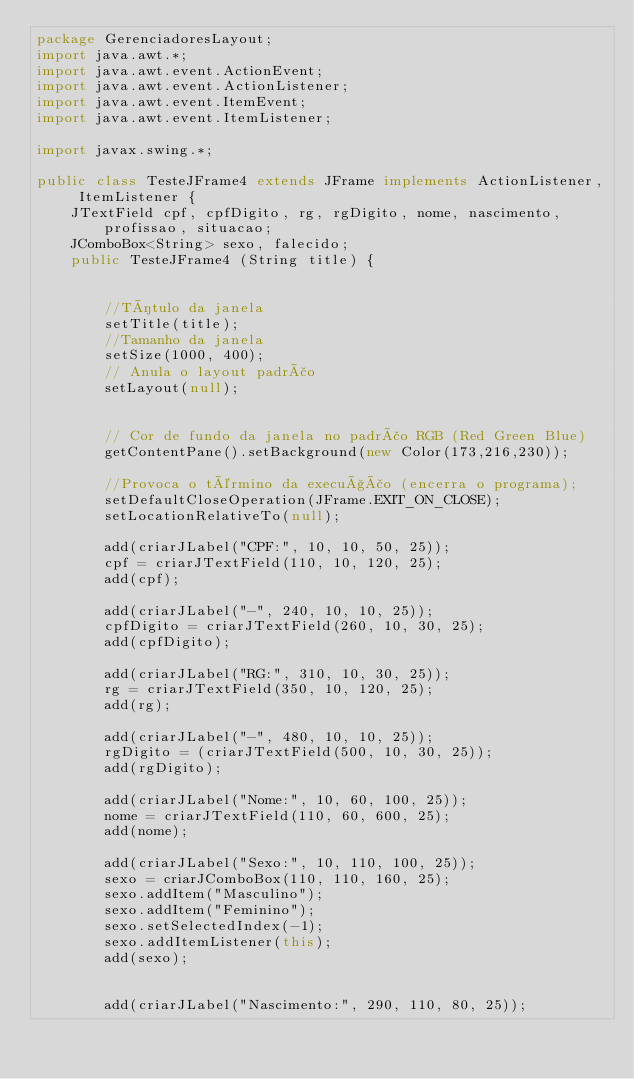Convert code to text. <code><loc_0><loc_0><loc_500><loc_500><_Java_>package GerenciadoresLayout;
import java.awt.*;
import java.awt.event.ActionEvent;
import java.awt.event.ActionListener;
import java.awt.event.ItemEvent;
import java.awt.event.ItemListener;

import javax.swing.*;

public class TesteJFrame4 extends JFrame implements ActionListener, ItemListener {
    JTextField cpf, cpfDigito, rg, rgDigito, nome, nascimento, profissao, situacao;
    JComboBox<String> sexo, falecido;
    public TesteJFrame4 (String title) {


        //Título da janela
        setTitle(title);
        //Tamanho da janela
        setSize(1000, 400);
        // Anula o layout padrão
        setLayout(null);


        // Cor de fundo da janela no padrão RGB (Red Green Blue)
        getContentPane().setBackground(new Color(173,216,230));

        //Provoca o término da execução (encerra o programa);
        setDefaultCloseOperation(JFrame.EXIT_ON_CLOSE);
        setLocationRelativeTo(null);

        add(criarJLabel("CPF:", 10, 10, 50, 25));
        cpf = criarJTextField(110, 10, 120, 25);
        add(cpf);

        add(criarJLabel("-", 240, 10, 10, 25));
        cpfDigito = criarJTextField(260, 10, 30, 25);
        add(cpfDigito);

        add(criarJLabel("RG:", 310, 10, 30, 25));
        rg = criarJTextField(350, 10, 120, 25);
        add(rg);

        add(criarJLabel("-", 480, 10, 10, 25));
        rgDigito = (criarJTextField(500, 10, 30, 25));
        add(rgDigito);

        add(criarJLabel("Nome:", 10, 60, 100, 25));
        nome = criarJTextField(110, 60, 600, 25);
        add(nome);

        add(criarJLabel("Sexo:", 10, 110, 100, 25));
        sexo = criarJComboBox(110, 110, 160, 25);
        sexo.addItem("Masculino");
        sexo.addItem("Feminino");
        sexo.setSelectedIndex(-1);
        sexo.addItemListener(this);
        add(sexo);


        add(criarJLabel("Nascimento:", 290, 110, 80, 25));</code> 